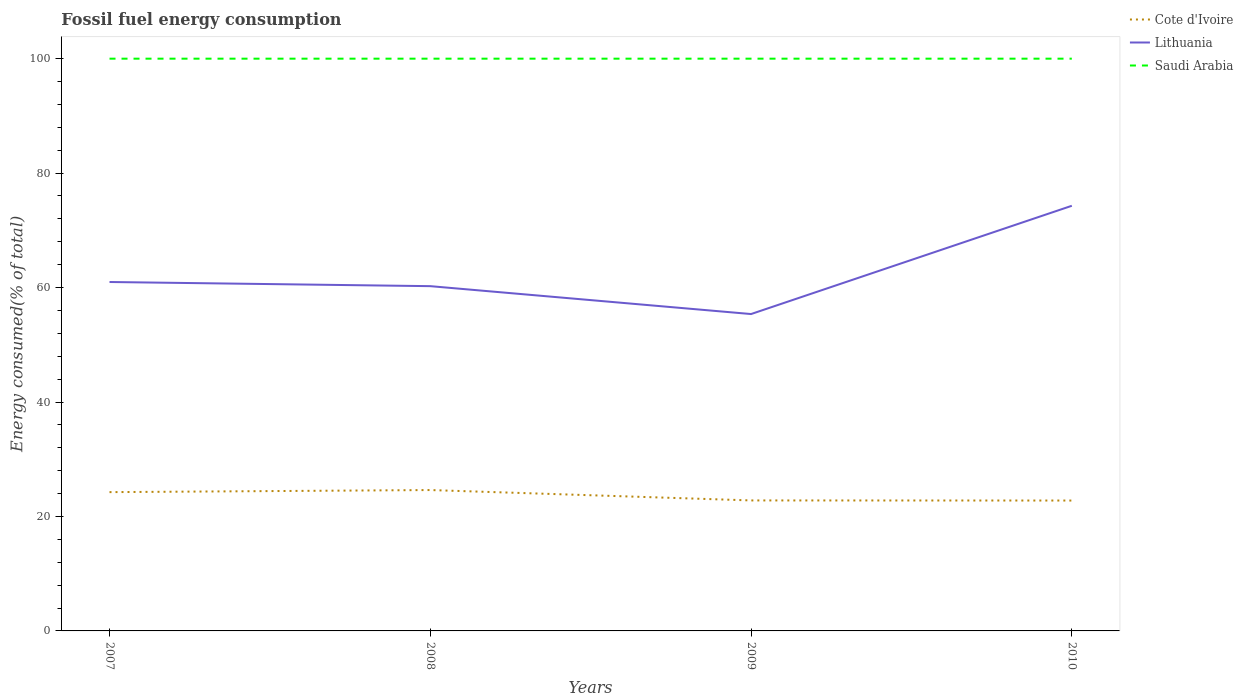Across all years, what is the maximum percentage of energy consumed in Cote d'Ivoire?
Offer a terse response. 22.78. In which year was the percentage of energy consumed in Cote d'Ivoire maximum?
Your answer should be compact. 2010. What is the total percentage of energy consumed in Saudi Arabia in the graph?
Provide a succinct answer. -0. What is the difference between the highest and the second highest percentage of energy consumed in Cote d'Ivoire?
Your answer should be very brief. 1.83. How many lines are there?
Make the answer very short. 3. What is the difference between two consecutive major ticks on the Y-axis?
Ensure brevity in your answer.  20. Are the values on the major ticks of Y-axis written in scientific E-notation?
Provide a short and direct response. No. Does the graph contain any zero values?
Your answer should be compact. No. Does the graph contain grids?
Ensure brevity in your answer.  No. Where does the legend appear in the graph?
Provide a short and direct response. Top right. What is the title of the graph?
Offer a very short reply. Fossil fuel energy consumption. What is the label or title of the X-axis?
Ensure brevity in your answer.  Years. What is the label or title of the Y-axis?
Your answer should be compact. Energy consumed(% of total). What is the Energy consumed(% of total) in Cote d'Ivoire in 2007?
Your answer should be compact. 24.25. What is the Energy consumed(% of total) in Lithuania in 2007?
Make the answer very short. 60.97. What is the Energy consumed(% of total) in Saudi Arabia in 2007?
Your response must be concise. 100. What is the Energy consumed(% of total) in Cote d'Ivoire in 2008?
Your answer should be very brief. 24.62. What is the Energy consumed(% of total) in Lithuania in 2008?
Give a very brief answer. 60.25. What is the Energy consumed(% of total) in Saudi Arabia in 2008?
Your answer should be compact. 100. What is the Energy consumed(% of total) of Cote d'Ivoire in 2009?
Keep it short and to the point. 22.8. What is the Energy consumed(% of total) of Lithuania in 2009?
Your answer should be very brief. 55.37. What is the Energy consumed(% of total) of Saudi Arabia in 2009?
Offer a terse response. 100. What is the Energy consumed(% of total) of Cote d'Ivoire in 2010?
Offer a terse response. 22.78. What is the Energy consumed(% of total) in Lithuania in 2010?
Give a very brief answer. 74.29. What is the Energy consumed(% of total) of Saudi Arabia in 2010?
Make the answer very short. 100. Across all years, what is the maximum Energy consumed(% of total) of Cote d'Ivoire?
Offer a terse response. 24.62. Across all years, what is the maximum Energy consumed(% of total) in Lithuania?
Your answer should be very brief. 74.29. Across all years, what is the maximum Energy consumed(% of total) of Saudi Arabia?
Your answer should be compact. 100. Across all years, what is the minimum Energy consumed(% of total) in Cote d'Ivoire?
Your answer should be compact. 22.78. Across all years, what is the minimum Energy consumed(% of total) in Lithuania?
Your response must be concise. 55.37. Across all years, what is the minimum Energy consumed(% of total) in Saudi Arabia?
Ensure brevity in your answer.  100. What is the total Energy consumed(% of total) of Cote d'Ivoire in the graph?
Your answer should be very brief. 94.45. What is the total Energy consumed(% of total) of Lithuania in the graph?
Ensure brevity in your answer.  250.88. What is the total Energy consumed(% of total) of Saudi Arabia in the graph?
Ensure brevity in your answer.  399.99. What is the difference between the Energy consumed(% of total) of Cote d'Ivoire in 2007 and that in 2008?
Keep it short and to the point. -0.36. What is the difference between the Energy consumed(% of total) of Lithuania in 2007 and that in 2008?
Keep it short and to the point. 0.73. What is the difference between the Energy consumed(% of total) in Saudi Arabia in 2007 and that in 2008?
Provide a succinct answer. -0. What is the difference between the Energy consumed(% of total) in Cote d'Ivoire in 2007 and that in 2009?
Offer a terse response. 1.45. What is the difference between the Energy consumed(% of total) of Lithuania in 2007 and that in 2009?
Offer a very short reply. 5.6. What is the difference between the Energy consumed(% of total) in Saudi Arabia in 2007 and that in 2009?
Make the answer very short. -0. What is the difference between the Energy consumed(% of total) of Cote d'Ivoire in 2007 and that in 2010?
Offer a very short reply. 1.47. What is the difference between the Energy consumed(% of total) in Lithuania in 2007 and that in 2010?
Give a very brief answer. -13.32. What is the difference between the Energy consumed(% of total) of Saudi Arabia in 2007 and that in 2010?
Your response must be concise. -0. What is the difference between the Energy consumed(% of total) of Cote d'Ivoire in 2008 and that in 2009?
Keep it short and to the point. 1.82. What is the difference between the Energy consumed(% of total) of Lithuania in 2008 and that in 2009?
Give a very brief answer. 4.87. What is the difference between the Energy consumed(% of total) of Saudi Arabia in 2008 and that in 2009?
Keep it short and to the point. -0. What is the difference between the Energy consumed(% of total) of Cote d'Ivoire in 2008 and that in 2010?
Provide a short and direct response. 1.83. What is the difference between the Energy consumed(% of total) of Lithuania in 2008 and that in 2010?
Your answer should be compact. -14.05. What is the difference between the Energy consumed(% of total) in Saudi Arabia in 2008 and that in 2010?
Your answer should be compact. -0. What is the difference between the Energy consumed(% of total) of Cote d'Ivoire in 2009 and that in 2010?
Keep it short and to the point. 0.02. What is the difference between the Energy consumed(% of total) of Lithuania in 2009 and that in 2010?
Offer a terse response. -18.92. What is the difference between the Energy consumed(% of total) in Saudi Arabia in 2009 and that in 2010?
Ensure brevity in your answer.  -0. What is the difference between the Energy consumed(% of total) in Cote d'Ivoire in 2007 and the Energy consumed(% of total) in Lithuania in 2008?
Offer a terse response. -35.99. What is the difference between the Energy consumed(% of total) in Cote d'Ivoire in 2007 and the Energy consumed(% of total) in Saudi Arabia in 2008?
Offer a very short reply. -75.74. What is the difference between the Energy consumed(% of total) of Lithuania in 2007 and the Energy consumed(% of total) of Saudi Arabia in 2008?
Your response must be concise. -39.03. What is the difference between the Energy consumed(% of total) in Cote d'Ivoire in 2007 and the Energy consumed(% of total) in Lithuania in 2009?
Your answer should be very brief. -31.12. What is the difference between the Energy consumed(% of total) of Cote d'Ivoire in 2007 and the Energy consumed(% of total) of Saudi Arabia in 2009?
Provide a succinct answer. -75.74. What is the difference between the Energy consumed(% of total) in Lithuania in 2007 and the Energy consumed(% of total) in Saudi Arabia in 2009?
Keep it short and to the point. -39.03. What is the difference between the Energy consumed(% of total) of Cote d'Ivoire in 2007 and the Energy consumed(% of total) of Lithuania in 2010?
Keep it short and to the point. -50.04. What is the difference between the Energy consumed(% of total) of Cote d'Ivoire in 2007 and the Energy consumed(% of total) of Saudi Arabia in 2010?
Your answer should be very brief. -75.74. What is the difference between the Energy consumed(% of total) of Lithuania in 2007 and the Energy consumed(% of total) of Saudi Arabia in 2010?
Your answer should be compact. -39.03. What is the difference between the Energy consumed(% of total) in Cote d'Ivoire in 2008 and the Energy consumed(% of total) in Lithuania in 2009?
Ensure brevity in your answer.  -30.75. What is the difference between the Energy consumed(% of total) in Cote d'Ivoire in 2008 and the Energy consumed(% of total) in Saudi Arabia in 2009?
Give a very brief answer. -75.38. What is the difference between the Energy consumed(% of total) in Lithuania in 2008 and the Energy consumed(% of total) in Saudi Arabia in 2009?
Your answer should be compact. -39.75. What is the difference between the Energy consumed(% of total) of Cote d'Ivoire in 2008 and the Energy consumed(% of total) of Lithuania in 2010?
Give a very brief answer. -49.67. What is the difference between the Energy consumed(% of total) of Cote d'Ivoire in 2008 and the Energy consumed(% of total) of Saudi Arabia in 2010?
Your response must be concise. -75.38. What is the difference between the Energy consumed(% of total) in Lithuania in 2008 and the Energy consumed(% of total) in Saudi Arabia in 2010?
Your response must be concise. -39.75. What is the difference between the Energy consumed(% of total) of Cote d'Ivoire in 2009 and the Energy consumed(% of total) of Lithuania in 2010?
Your response must be concise. -51.49. What is the difference between the Energy consumed(% of total) in Cote d'Ivoire in 2009 and the Energy consumed(% of total) in Saudi Arabia in 2010?
Offer a terse response. -77.2. What is the difference between the Energy consumed(% of total) of Lithuania in 2009 and the Energy consumed(% of total) of Saudi Arabia in 2010?
Make the answer very short. -44.63. What is the average Energy consumed(% of total) of Cote d'Ivoire per year?
Give a very brief answer. 23.61. What is the average Energy consumed(% of total) in Lithuania per year?
Your answer should be very brief. 62.72. What is the average Energy consumed(% of total) in Saudi Arabia per year?
Your answer should be compact. 100. In the year 2007, what is the difference between the Energy consumed(% of total) of Cote d'Ivoire and Energy consumed(% of total) of Lithuania?
Ensure brevity in your answer.  -36.72. In the year 2007, what is the difference between the Energy consumed(% of total) in Cote d'Ivoire and Energy consumed(% of total) in Saudi Arabia?
Ensure brevity in your answer.  -75.74. In the year 2007, what is the difference between the Energy consumed(% of total) of Lithuania and Energy consumed(% of total) of Saudi Arabia?
Your response must be concise. -39.03. In the year 2008, what is the difference between the Energy consumed(% of total) in Cote d'Ivoire and Energy consumed(% of total) in Lithuania?
Offer a terse response. -35.63. In the year 2008, what is the difference between the Energy consumed(% of total) in Cote d'Ivoire and Energy consumed(% of total) in Saudi Arabia?
Your answer should be compact. -75.38. In the year 2008, what is the difference between the Energy consumed(% of total) of Lithuania and Energy consumed(% of total) of Saudi Arabia?
Your answer should be very brief. -39.75. In the year 2009, what is the difference between the Energy consumed(% of total) in Cote d'Ivoire and Energy consumed(% of total) in Lithuania?
Offer a very short reply. -32.57. In the year 2009, what is the difference between the Energy consumed(% of total) in Cote d'Ivoire and Energy consumed(% of total) in Saudi Arabia?
Ensure brevity in your answer.  -77.19. In the year 2009, what is the difference between the Energy consumed(% of total) of Lithuania and Energy consumed(% of total) of Saudi Arabia?
Make the answer very short. -44.63. In the year 2010, what is the difference between the Energy consumed(% of total) in Cote d'Ivoire and Energy consumed(% of total) in Lithuania?
Ensure brevity in your answer.  -51.51. In the year 2010, what is the difference between the Energy consumed(% of total) of Cote d'Ivoire and Energy consumed(% of total) of Saudi Arabia?
Provide a succinct answer. -77.21. In the year 2010, what is the difference between the Energy consumed(% of total) in Lithuania and Energy consumed(% of total) in Saudi Arabia?
Your answer should be very brief. -25.71. What is the ratio of the Energy consumed(% of total) of Cote d'Ivoire in 2007 to that in 2008?
Provide a short and direct response. 0.99. What is the ratio of the Energy consumed(% of total) in Lithuania in 2007 to that in 2008?
Keep it short and to the point. 1.01. What is the ratio of the Energy consumed(% of total) of Cote d'Ivoire in 2007 to that in 2009?
Provide a short and direct response. 1.06. What is the ratio of the Energy consumed(% of total) of Lithuania in 2007 to that in 2009?
Your answer should be compact. 1.1. What is the ratio of the Energy consumed(% of total) in Cote d'Ivoire in 2007 to that in 2010?
Offer a very short reply. 1.06. What is the ratio of the Energy consumed(% of total) of Lithuania in 2007 to that in 2010?
Ensure brevity in your answer.  0.82. What is the ratio of the Energy consumed(% of total) in Cote d'Ivoire in 2008 to that in 2009?
Your response must be concise. 1.08. What is the ratio of the Energy consumed(% of total) of Lithuania in 2008 to that in 2009?
Ensure brevity in your answer.  1.09. What is the ratio of the Energy consumed(% of total) in Cote d'Ivoire in 2008 to that in 2010?
Provide a succinct answer. 1.08. What is the ratio of the Energy consumed(% of total) in Lithuania in 2008 to that in 2010?
Offer a terse response. 0.81. What is the ratio of the Energy consumed(% of total) of Saudi Arabia in 2008 to that in 2010?
Give a very brief answer. 1. What is the ratio of the Energy consumed(% of total) of Cote d'Ivoire in 2009 to that in 2010?
Provide a succinct answer. 1. What is the ratio of the Energy consumed(% of total) of Lithuania in 2009 to that in 2010?
Your answer should be very brief. 0.75. What is the ratio of the Energy consumed(% of total) in Saudi Arabia in 2009 to that in 2010?
Make the answer very short. 1. What is the difference between the highest and the second highest Energy consumed(% of total) in Cote d'Ivoire?
Provide a succinct answer. 0.36. What is the difference between the highest and the second highest Energy consumed(% of total) in Lithuania?
Ensure brevity in your answer.  13.32. What is the difference between the highest and the lowest Energy consumed(% of total) in Cote d'Ivoire?
Your response must be concise. 1.83. What is the difference between the highest and the lowest Energy consumed(% of total) of Lithuania?
Make the answer very short. 18.92. What is the difference between the highest and the lowest Energy consumed(% of total) of Saudi Arabia?
Your answer should be compact. 0. 